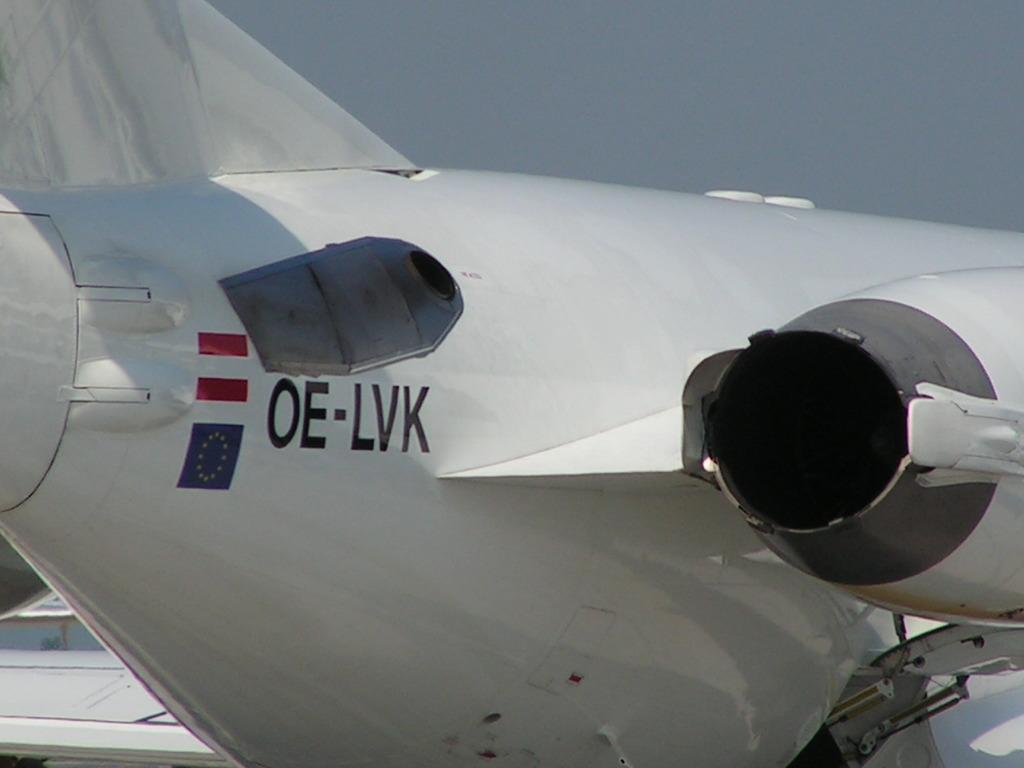<image>
Share a concise interpretation of the image provided. An airplane wiht the code OE-LVK also has two red stripes on it. 